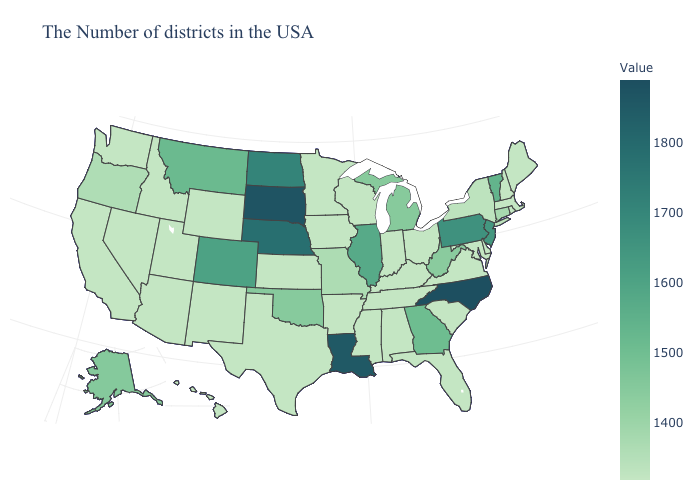Which states have the lowest value in the South?
Answer briefly. Delaware, Maryland, Virginia, South Carolina, Florida, Kentucky, Alabama, Tennessee, Mississippi, Arkansas, Texas. Does Pennsylvania have the highest value in the USA?
Concise answer only. No. Which states hav the highest value in the MidWest?
Give a very brief answer. South Dakota. Among the states that border Nevada , does Oregon have the highest value?
Quick response, please. Yes. Does the map have missing data?
Quick response, please. No. Does the map have missing data?
Be succinct. No. Does Massachusetts have the highest value in the USA?
Concise answer only. No. Does Georgia have a lower value than Indiana?
Answer briefly. No. 